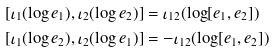<formula> <loc_0><loc_0><loc_500><loc_500>[ \iota _ { 1 } ( \log e _ { 1 } ) , \iota _ { 2 } ( \log e _ { 2 } ) ] & = \iota _ { 1 2 } ( \log [ e _ { 1 } , e _ { 2 } ] ) \\ [ \iota _ { 1 } ( \log e _ { 2 } ) , \iota _ { 2 } ( \log e _ { 1 } ) ] & = - \iota _ { 1 2 } ( \log [ e _ { 1 } , e _ { 2 } ] )</formula> 